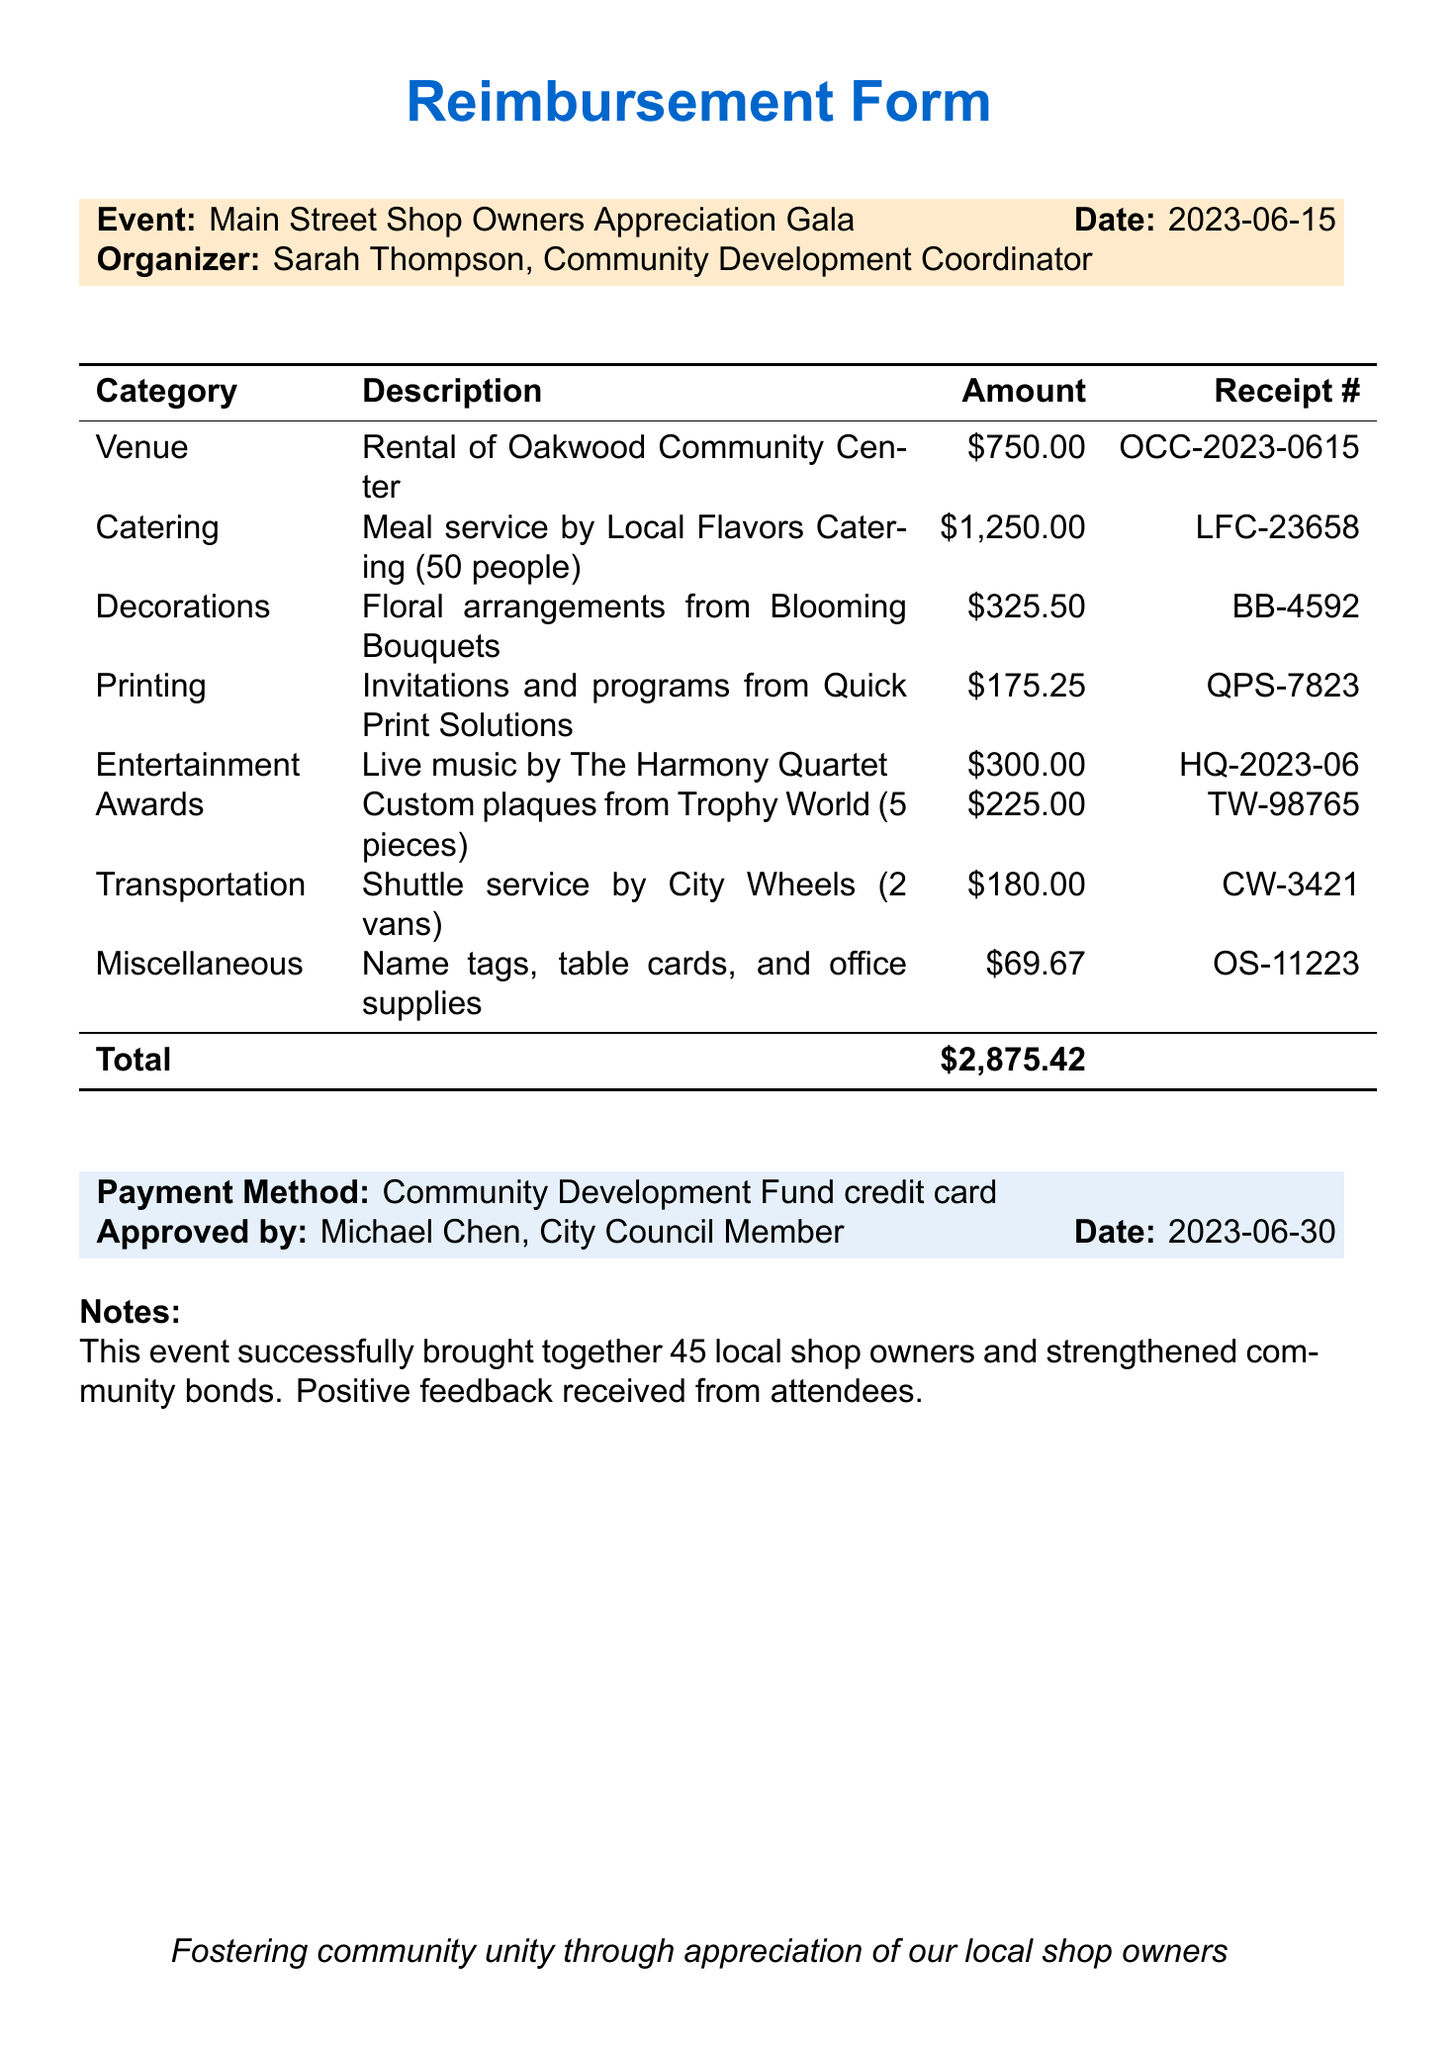What is the event name? The event name is stated at the beginning of the document.
Answer: Main Street Shop Owners Appreciation Gala Who organized the event? The organizer's name and title are provided in the document.
Answer: Sarah Thompson What was the total amount of expenses? The total amount is clearly listed in the document's summary.
Answer: 2875.42 How many shop owners attended the event? The notes section mentions the number of attendees.
Answer: 45 What was the rental cost for the venue? The expense items include the venue rental cost specifically.
Answer: 750.00 Who approved the reimbursement? The approver's name is mentioned in the payment details of the document.
Answer: Michael Chen What was the date of the event? The event date is given in the header section of the document.
Answer: 2023-06-15 Which category had the highest expense? The expense items can be compared for their amounts to find the highest.
Answer: Catering What type of services did the catering provide? The description of the catering expense provides insight into the service type.
Answer: Meal service by Local Flavors Catering (50 people) What is the payment method used for the expenses? The payment method is explicitly stated in the document.
Answer: Community Development Fund credit card 